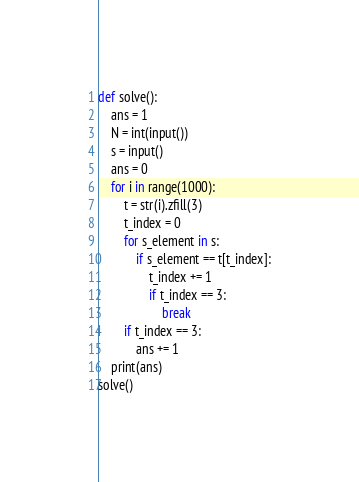Convert code to text. <code><loc_0><loc_0><loc_500><loc_500><_Python_>def solve():
    ans = 1
    N = int(input())
    s = input()
    ans = 0
    for i in range(1000):
    	t = str(i).zfill(3)
    	t_index = 0 
    	for s_element in s:
    		if s_element == t[t_index]:
    			t_index += 1
    			if t_index == 3:
    				break
    	if t_index == 3:
    		ans += 1
    print(ans)
solve()</code> 